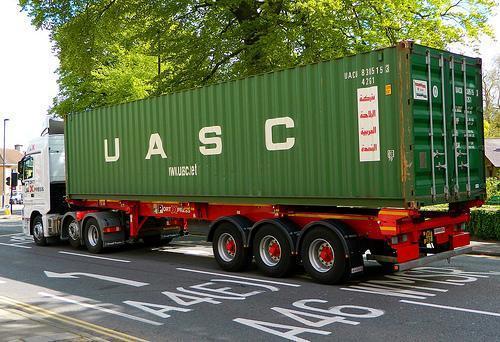How many trucks are there?
Give a very brief answer. 1. 